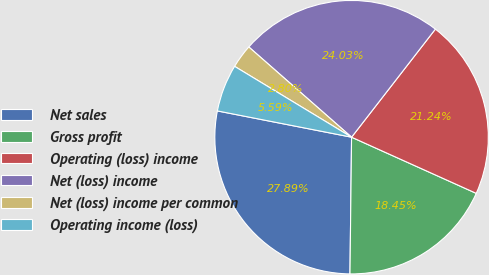Convert chart. <chart><loc_0><loc_0><loc_500><loc_500><pie_chart><fcel>Net sales<fcel>Gross profit<fcel>Operating (loss) income<fcel>Net (loss) income<fcel>Net (loss) income per common<fcel>Operating income (loss)<nl><fcel>27.89%<fcel>18.45%<fcel>21.24%<fcel>24.03%<fcel>2.8%<fcel>5.59%<nl></chart> 